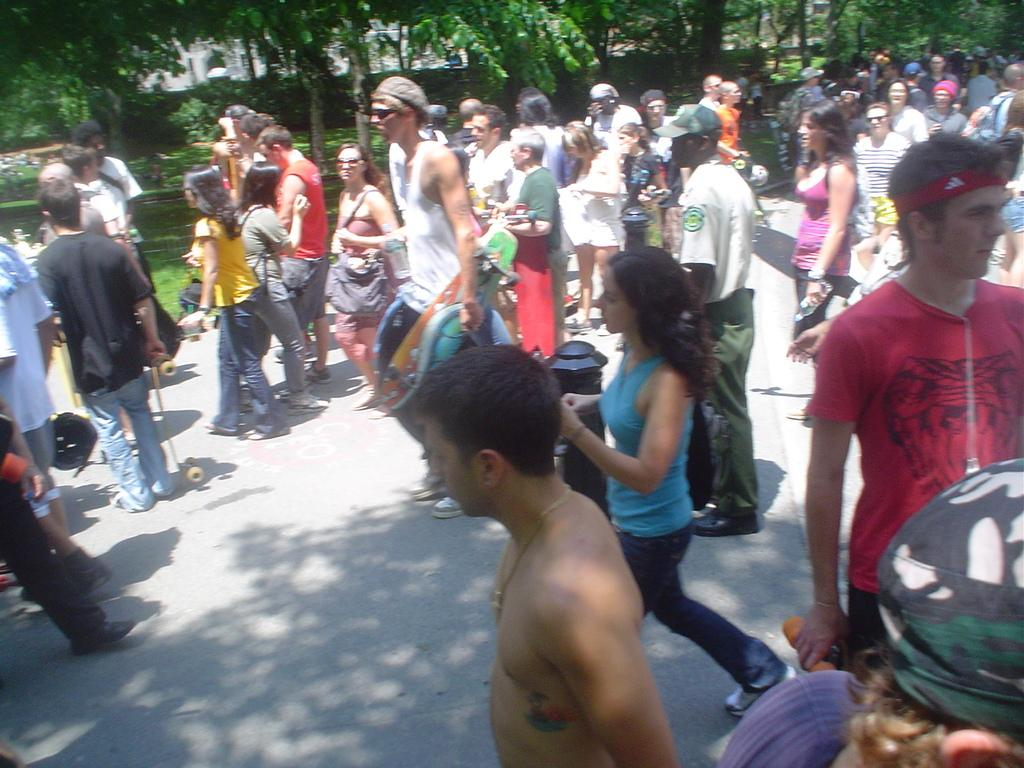What can be seen at the bottom of the image? There are persons in different color dresses at the bottom of the image. Where are the persons located? The persons are on a road. What is visible in the background of the image? There are trees, plants, and grass on the ground in the background of the image. What type of lamp is being carried by the person in the image? There is no lamp present in the image; the persons are not carrying any objects. 